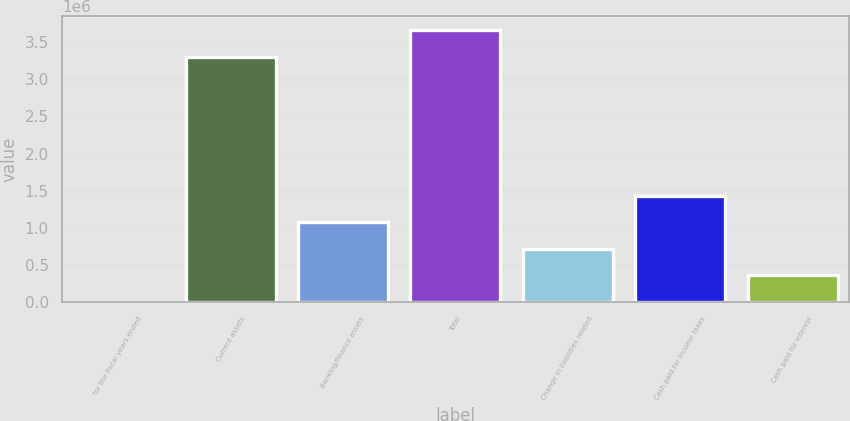Convert chart. <chart><loc_0><loc_0><loc_500><loc_500><bar_chart><fcel>for the fiscal years ended<fcel>Current assets<fcel>Banking/finance assets<fcel>Total<fcel>Change in liabilities related<fcel>Cash paid for income taxes<fcel>Cash paid for interest<nl><fcel>2008<fcel>3.3045e+06<fcel>1.07666e+06<fcel>3.66271e+06<fcel>718443<fcel>1.43488e+06<fcel>360226<nl></chart> 